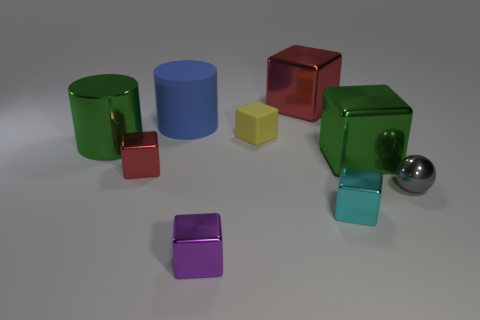There is a large object behind the blue thing; does it have the same shape as the blue matte thing?
Give a very brief answer. No. How many cyan objects are large blocks or objects?
Give a very brief answer. 1. There is a cyan thing that is the same shape as the purple metallic object; what is it made of?
Provide a succinct answer. Metal. There is a big metal thing behind the large green cylinder; what is its shape?
Offer a terse response. Cube. Is there a tiny green cube made of the same material as the large red thing?
Keep it short and to the point. No. Does the metal cylinder have the same size as the cyan metallic cube?
Provide a short and direct response. No. How many cubes are green objects or tiny cyan shiny things?
Provide a short and direct response. 2. What is the material of the large thing that is the same color as the shiny cylinder?
Offer a terse response. Metal. How many tiny green matte objects have the same shape as the blue thing?
Ensure brevity in your answer.  0. Is the number of tiny red blocks that are left of the blue rubber cylinder greater than the number of big blue objects that are right of the yellow cube?
Offer a terse response. Yes. 